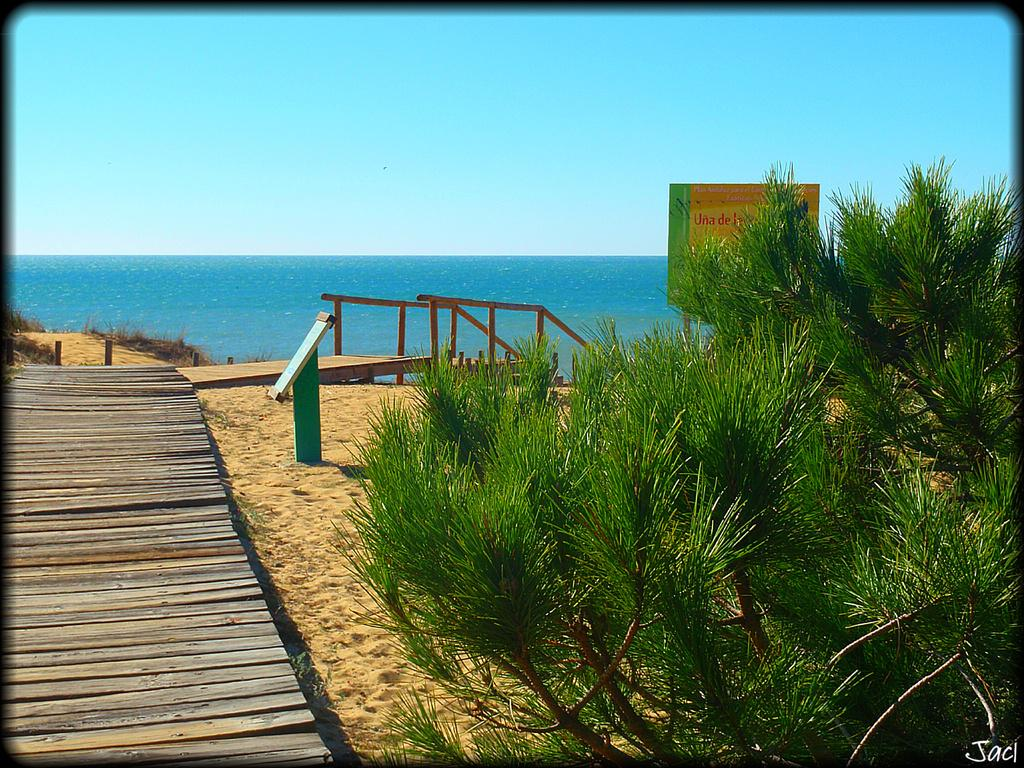What type of path is visible in the image? There is a wooden path in the image. What is located near the wooden path? There is a board near the near the wooden path. What type of vegetation is present in the image? There are plants in the image. What can be seen in the background of the image? There is a railing, water, and the sky visible in the background. What type of scent can be detected from the wooden path in the image? There is no information about the scent of the wooden path in the image, as it is a visual medium. 